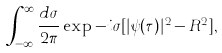Convert formula to latex. <formula><loc_0><loc_0><loc_500><loc_500>\int _ { - \infty } ^ { \infty } \frac { d \sigma } { 2 \pi } \exp - i \sigma [ | \psi ( \tau ) | ^ { 2 } - R ^ { 2 } ] ,</formula> 